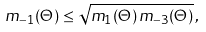Convert formula to latex. <formula><loc_0><loc_0><loc_500><loc_500>m _ { - 1 } ( \Theta ) \leq \sqrt { m _ { 1 } ( \Theta ) \, m _ { - 3 } ( \Theta ) } \, ,</formula> 